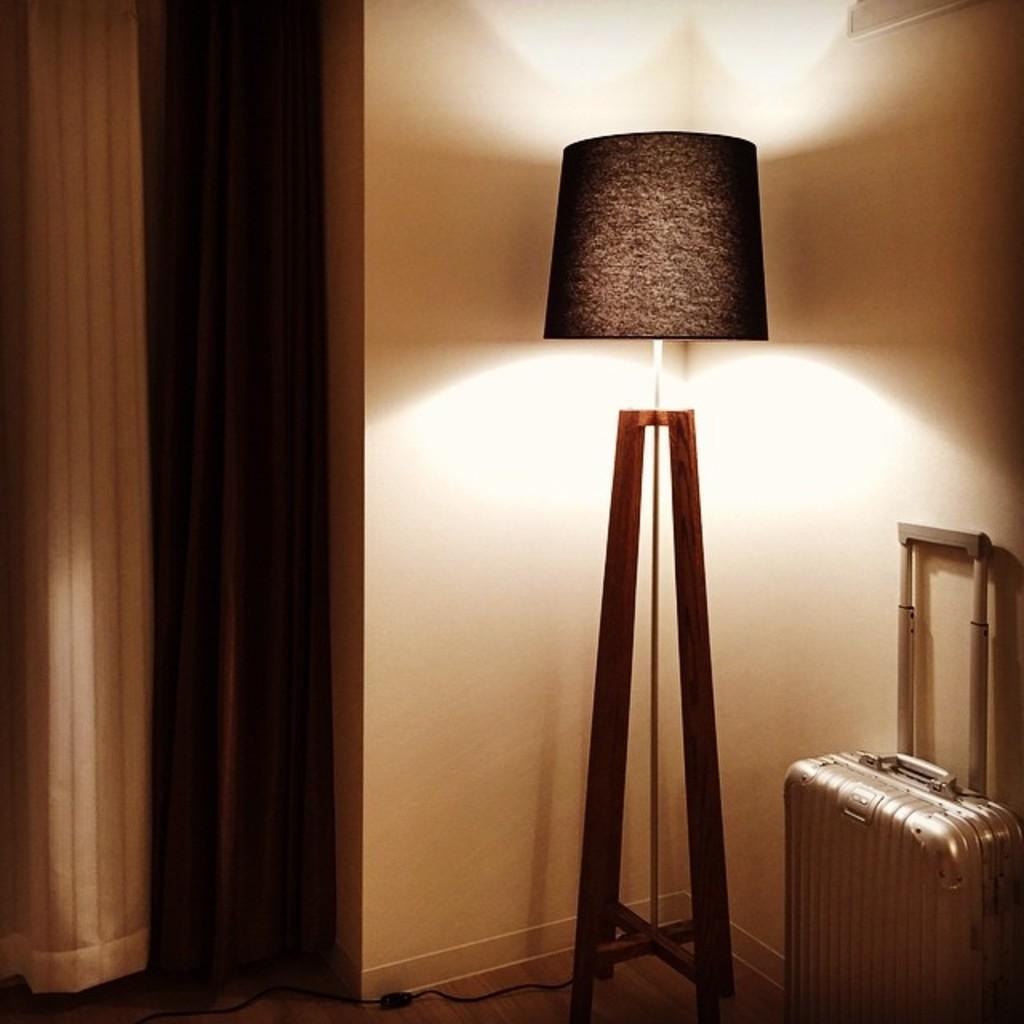Describe this image in one or two sentences. In this image we can see a suitcase, there is a lamp on the stand, also we can see the curtain, and the wall. 